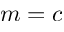Convert formula to latex. <formula><loc_0><loc_0><loc_500><loc_500>m = c</formula> 